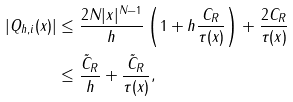<formula> <loc_0><loc_0><loc_500><loc_500>| Q _ { h , i } ( x ) | & \leq \frac { 2 N | x | ^ { N - 1 } } { h } \left ( 1 + h \frac { C _ { R } } { \tau ( x ) } \right ) + \frac { 2 C _ { R } } { \tau ( x ) } \\ & \leq \frac { \tilde { C } _ { R } } { h } + \frac { \tilde { C } _ { R } } { \tau ( x ) } ,</formula> 